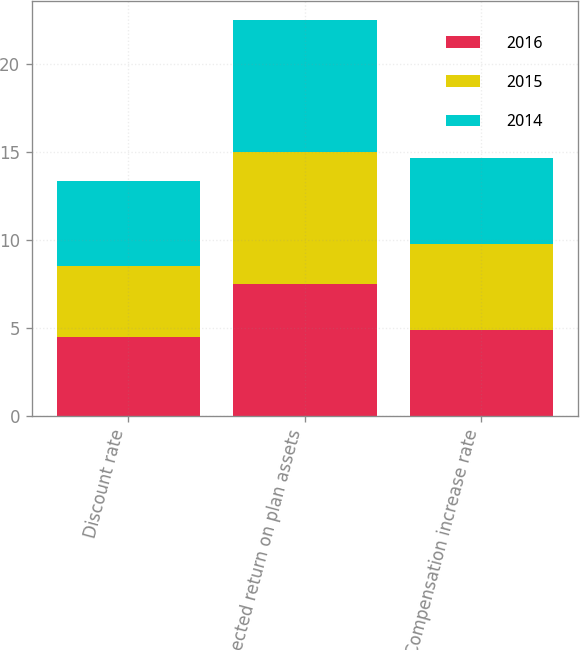<chart> <loc_0><loc_0><loc_500><loc_500><stacked_bar_chart><ecel><fcel>Discount rate<fcel>Expected return on plan assets<fcel>Compensation increase rate<nl><fcel>2016<fcel>4.47<fcel>7.5<fcel>4.87<nl><fcel>2015<fcel>4.07<fcel>7.5<fcel>4.88<nl><fcel>2014<fcel>4.83<fcel>7.5<fcel>4.91<nl></chart> 